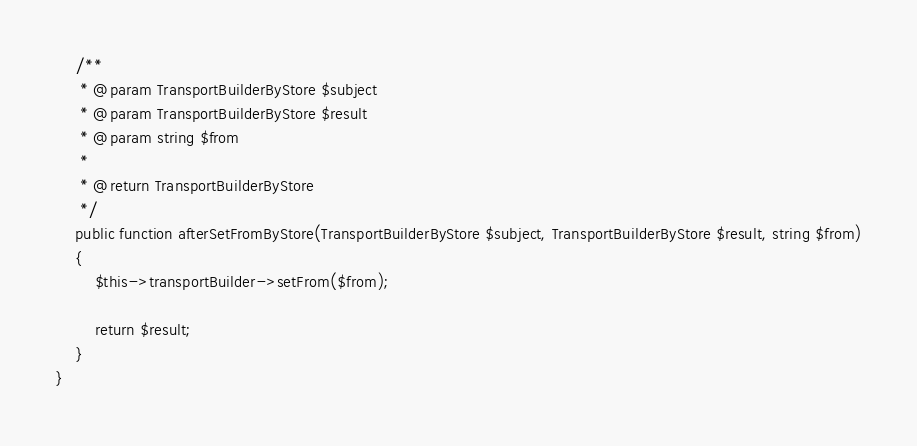Convert code to text. <code><loc_0><loc_0><loc_500><loc_500><_PHP_>
    /**
     * @param TransportBuilderByStore $subject
     * @param TransportBuilderByStore $result
     * @param string $from
     *
     * @return TransportBuilderByStore
     */
    public function afterSetFromByStore(TransportBuilderByStore $subject, TransportBuilderByStore $result, string $from)
    {
        $this->transportBuilder->setFrom($from);

        return $result;
    }
}
</code> 